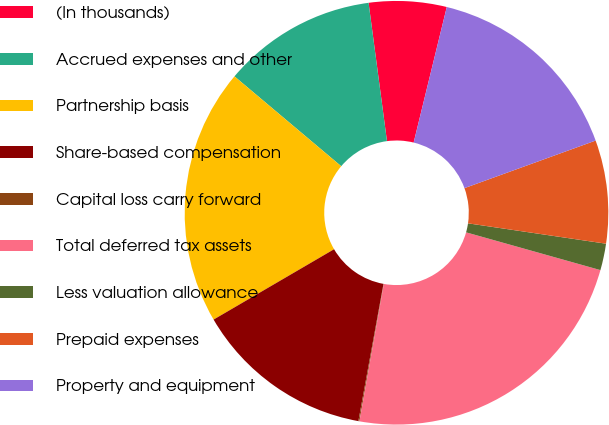<chart> <loc_0><loc_0><loc_500><loc_500><pie_chart><fcel>(In thousands)<fcel>Accrued expenses and other<fcel>Partnership basis<fcel>Share-based compensation<fcel>Capital loss carry forward<fcel>Total deferred tax assets<fcel>Less valuation allowance<fcel>Prepaid expenses<fcel>Property and equipment<nl><fcel>5.92%<fcel>11.76%<fcel>19.55%<fcel>13.71%<fcel>0.08%<fcel>23.44%<fcel>2.03%<fcel>7.87%<fcel>15.65%<nl></chart> 